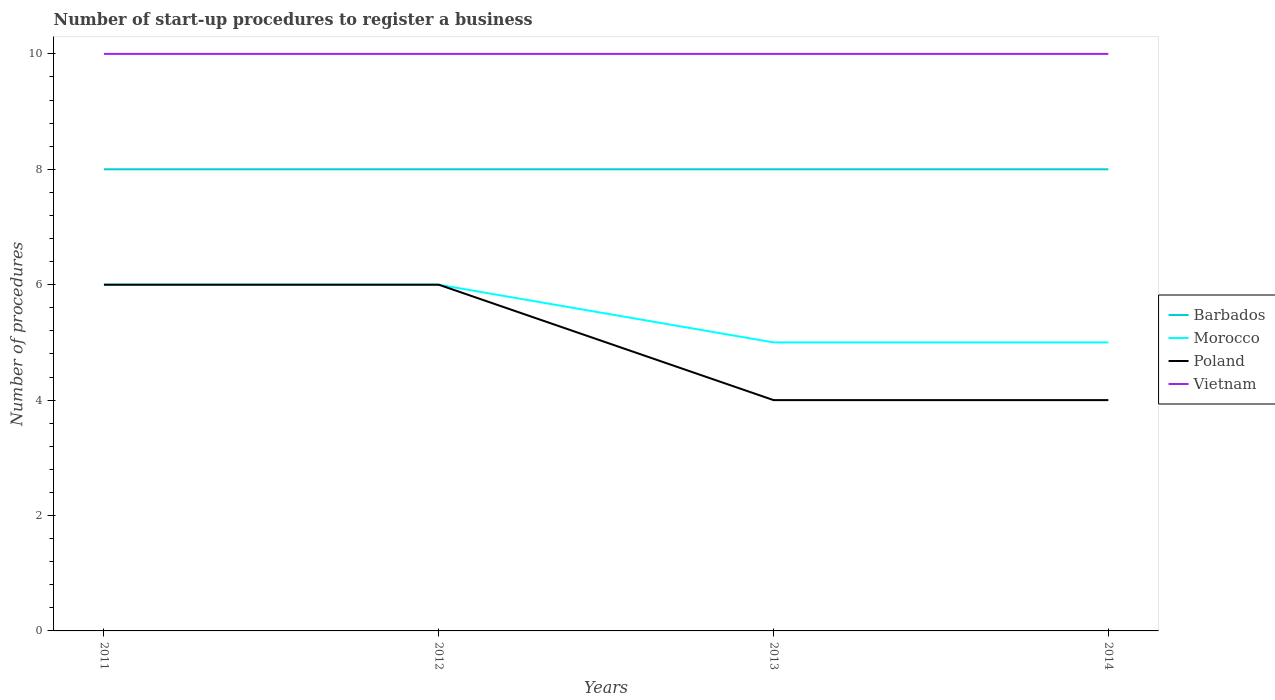Is the number of lines equal to the number of legend labels?
Provide a short and direct response. Yes. What is the total number of procedures required to register a business in Barbados in the graph?
Keep it short and to the point. 0. What is the difference between the highest and the second highest number of procedures required to register a business in Vietnam?
Provide a short and direct response. 0. How many lines are there?
Ensure brevity in your answer.  4. How many years are there in the graph?
Make the answer very short. 4. What is the difference between two consecutive major ticks on the Y-axis?
Ensure brevity in your answer.  2. Where does the legend appear in the graph?
Offer a very short reply. Center right. What is the title of the graph?
Offer a terse response. Number of start-up procedures to register a business. What is the label or title of the Y-axis?
Give a very brief answer. Number of procedures. What is the Number of procedures of Barbados in 2011?
Your answer should be compact. 8. What is the Number of procedures in Morocco in 2011?
Provide a succinct answer. 6. What is the Number of procedures of Poland in 2011?
Offer a terse response. 6. What is the Number of procedures in Vietnam in 2011?
Give a very brief answer. 10. What is the Number of procedures of Barbados in 2012?
Offer a terse response. 8. What is the Number of procedures of Morocco in 2012?
Give a very brief answer. 6. What is the Number of procedures in Poland in 2012?
Your answer should be compact. 6. What is the Number of procedures in Barbados in 2013?
Ensure brevity in your answer.  8. What is the Number of procedures of Poland in 2013?
Keep it short and to the point. 4. What is the Number of procedures in Vietnam in 2013?
Ensure brevity in your answer.  10. What is the Number of procedures in Poland in 2014?
Your answer should be compact. 4. What is the Number of procedures in Vietnam in 2014?
Your response must be concise. 10. Across all years, what is the maximum Number of procedures in Morocco?
Ensure brevity in your answer.  6. Across all years, what is the maximum Number of procedures of Vietnam?
Ensure brevity in your answer.  10. Across all years, what is the minimum Number of procedures of Barbados?
Your answer should be compact. 8. Across all years, what is the minimum Number of procedures in Morocco?
Keep it short and to the point. 5. Across all years, what is the minimum Number of procedures of Vietnam?
Provide a short and direct response. 10. What is the total Number of procedures in Poland in the graph?
Provide a succinct answer. 20. What is the difference between the Number of procedures in Barbados in 2011 and that in 2013?
Provide a short and direct response. 0. What is the difference between the Number of procedures in Poland in 2011 and that in 2013?
Offer a very short reply. 2. What is the difference between the Number of procedures of Barbados in 2011 and that in 2014?
Provide a short and direct response. 0. What is the difference between the Number of procedures in Barbados in 2012 and that in 2013?
Keep it short and to the point. 0. What is the difference between the Number of procedures of Morocco in 2012 and that in 2013?
Provide a short and direct response. 1. What is the difference between the Number of procedures in Barbados in 2012 and that in 2014?
Your response must be concise. 0. What is the difference between the Number of procedures in Poland in 2012 and that in 2014?
Offer a very short reply. 2. What is the difference between the Number of procedures in Vietnam in 2012 and that in 2014?
Your response must be concise. 0. What is the difference between the Number of procedures of Barbados in 2013 and that in 2014?
Your answer should be very brief. 0. What is the difference between the Number of procedures in Morocco in 2013 and that in 2014?
Your answer should be very brief. 0. What is the difference between the Number of procedures of Barbados in 2011 and the Number of procedures of Poland in 2012?
Your response must be concise. 2. What is the difference between the Number of procedures of Barbados in 2011 and the Number of procedures of Vietnam in 2012?
Give a very brief answer. -2. What is the difference between the Number of procedures in Poland in 2011 and the Number of procedures in Vietnam in 2012?
Your response must be concise. -4. What is the difference between the Number of procedures of Barbados in 2011 and the Number of procedures of Morocco in 2013?
Offer a terse response. 3. What is the difference between the Number of procedures of Barbados in 2011 and the Number of procedures of Poland in 2013?
Your response must be concise. 4. What is the difference between the Number of procedures of Barbados in 2011 and the Number of procedures of Vietnam in 2013?
Offer a very short reply. -2. What is the difference between the Number of procedures in Morocco in 2011 and the Number of procedures in Poland in 2013?
Provide a short and direct response. 2. What is the difference between the Number of procedures of Morocco in 2011 and the Number of procedures of Vietnam in 2013?
Your answer should be compact. -4. What is the difference between the Number of procedures of Poland in 2011 and the Number of procedures of Vietnam in 2013?
Your answer should be very brief. -4. What is the difference between the Number of procedures of Barbados in 2011 and the Number of procedures of Poland in 2014?
Your response must be concise. 4. What is the difference between the Number of procedures of Morocco in 2011 and the Number of procedures of Vietnam in 2014?
Offer a very short reply. -4. What is the difference between the Number of procedures in Barbados in 2012 and the Number of procedures in Morocco in 2013?
Offer a terse response. 3. What is the difference between the Number of procedures in Morocco in 2012 and the Number of procedures in Vietnam in 2013?
Give a very brief answer. -4. What is the difference between the Number of procedures of Barbados in 2012 and the Number of procedures of Morocco in 2014?
Offer a very short reply. 3. What is the difference between the Number of procedures of Barbados in 2012 and the Number of procedures of Poland in 2014?
Your answer should be compact. 4. What is the difference between the Number of procedures of Barbados in 2012 and the Number of procedures of Vietnam in 2014?
Ensure brevity in your answer.  -2. What is the difference between the Number of procedures in Morocco in 2012 and the Number of procedures in Poland in 2014?
Provide a short and direct response. 2. What is the difference between the Number of procedures of Morocco in 2012 and the Number of procedures of Vietnam in 2014?
Ensure brevity in your answer.  -4. What is the difference between the Number of procedures in Poland in 2012 and the Number of procedures in Vietnam in 2014?
Offer a very short reply. -4. What is the difference between the Number of procedures of Barbados in 2013 and the Number of procedures of Morocco in 2014?
Your answer should be compact. 3. What is the difference between the Number of procedures in Barbados in 2013 and the Number of procedures in Vietnam in 2014?
Provide a short and direct response. -2. What is the difference between the Number of procedures of Morocco in 2013 and the Number of procedures of Vietnam in 2014?
Give a very brief answer. -5. What is the difference between the Number of procedures in Poland in 2013 and the Number of procedures in Vietnam in 2014?
Your response must be concise. -6. What is the average Number of procedures of Barbados per year?
Provide a short and direct response. 8. What is the average Number of procedures in Morocco per year?
Provide a succinct answer. 5.5. What is the average Number of procedures in Vietnam per year?
Your response must be concise. 10. In the year 2011, what is the difference between the Number of procedures of Barbados and Number of procedures of Poland?
Your response must be concise. 2. In the year 2011, what is the difference between the Number of procedures of Barbados and Number of procedures of Vietnam?
Offer a very short reply. -2. In the year 2011, what is the difference between the Number of procedures in Morocco and Number of procedures in Vietnam?
Provide a succinct answer. -4. In the year 2012, what is the difference between the Number of procedures of Barbados and Number of procedures of Morocco?
Your response must be concise. 2. In the year 2012, what is the difference between the Number of procedures in Barbados and Number of procedures in Poland?
Your answer should be very brief. 2. In the year 2012, what is the difference between the Number of procedures in Barbados and Number of procedures in Vietnam?
Ensure brevity in your answer.  -2. In the year 2012, what is the difference between the Number of procedures in Morocco and Number of procedures in Poland?
Offer a terse response. 0. In the year 2012, what is the difference between the Number of procedures of Morocco and Number of procedures of Vietnam?
Keep it short and to the point. -4. In the year 2012, what is the difference between the Number of procedures in Poland and Number of procedures in Vietnam?
Offer a terse response. -4. In the year 2013, what is the difference between the Number of procedures in Barbados and Number of procedures in Vietnam?
Your response must be concise. -2. In the year 2013, what is the difference between the Number of procedures in Morocco and Number of procedures in Poland?
Ensure brevity in your answer.  1. In the year 2013, what is the difference between the Number of procedures in Poland and Number of procedures in Vietnam?
Make the answer very short. -6. In the year 2014, what is the difference between the Number of procedures of Morocco and Number of procedures of Poland?
Your answer should be very brief. 1. What is the ratio of the Number of procedures in Barbados in 2011 to that in 2012?
Ensure brevity in your answer.  1. What is the ratio of the Number of procedures of Poland in 2011 to that in 2012?
Ensure brevity in your answer.  1. What is the ratio of the Number of procedures of Vietnam in 2011 to that in 2012?
Provide a succinct answer. 1. What is the ratio of the Number of procedures in Morocco in 2011 to that in 2013?
Your response must be concise. 1.2. What is the ratio of the Number of procedures of Vietnam in 2011 to that in 2013?
Give a very brief answer. 1. What is the ratio of the Number of procedures of Vietnam in 2011 to that in 2014?
Ensure brevity in your answer.  1. What is the ratio of the Number of procedures in Morocco in 2012 to that in 2013?
Give a very brief answer. 1.2. What is the ratio of the Number of procedures of Poland in 2012 to that in 2013?
Your response must be concise. 1.5. What is the ratio of the Number of procedures of Morocco in 2012 to that in 2014?
Your answer should be very brief. 1.2. What is the ratio of the Number of procedures of Poland in 2012 to that in 2014?
Give a very brief answer. 1.5. What is the ratio of the Number of procedures of Vietnam in 2012 to that in 2014?
Offer a terse response. 1. What is the ratio of the Number of procedures in Barbados in 2013 to that in 2014?
Make the answer very short. 1. What is the ratio of the Number of procedures of Poland in 2013 to that in 2014?
Provide a succinct answer. 1. What is the ratio of the Number of procedures of Vietnam in 2013 to that in 2014?
Make the answer very short. 1. What is the difference between the highest and the second highest Number of procedures in Barbados?
Ensure brevity in your answer.  0. What is the difference between the highest and the second highest Number of procedures in Morocco?
Ensure brevity in your answer.  0. What is the difference between the highest and the second highest Number of procedures in Poland?
Provide a short and direct response. 0. What is the difference between the highest and the second highest Number of procedures of Vietnam?
Provide a short and direct response. 0. What is the difference between the highest and the lowest Number of procedures in Poland?
Keep it short and to the point. 2. What is the difference between the highest and the lowest Number of procedures in Vietnam?
Keep it short and to the point. 0. 